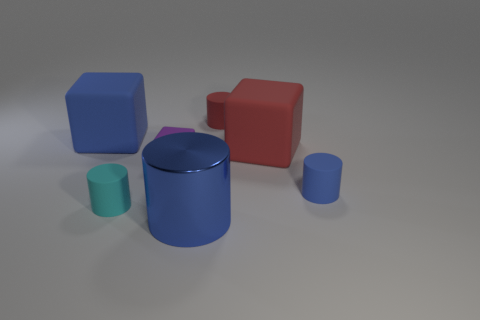What color is the matte thing that is behind the small matte cube and on the left side of the large shiny thing?
Offer a very short reply. Blue. There is a cylinder on the left side of the purple block; what is its size?
Your answer should be very brief. Small. What number of tiny blocks have the same material as the large blue block?
Keep it short and to the point. 1. What is the shape of the large matte object that is the same color as the big cylinder?
Keep it short and to the point. Cube. There is a big thing to the left of the big shiny object; is its shape the same as the tiny red object?
Offer a very short reply. No. The tiny block that is the same material as the cyan thing is what color?
Keep it short and to the point. Purple. Are there any large cubes on the right side of the large block that is on the right side of the rubber cylinder that is in front of the small blue cylinder?
Give a very brief answer. No. There is a big blue matte object; what shape is it?
Make the answer very short. Cube. Are there fewer cyan matte cylinders behind the cyan cylinder than small red objects?
Your answer should be very brief. Yes. Are there any other small matte objects of the same shape as the small purple object?
Make the answer very short. No. 